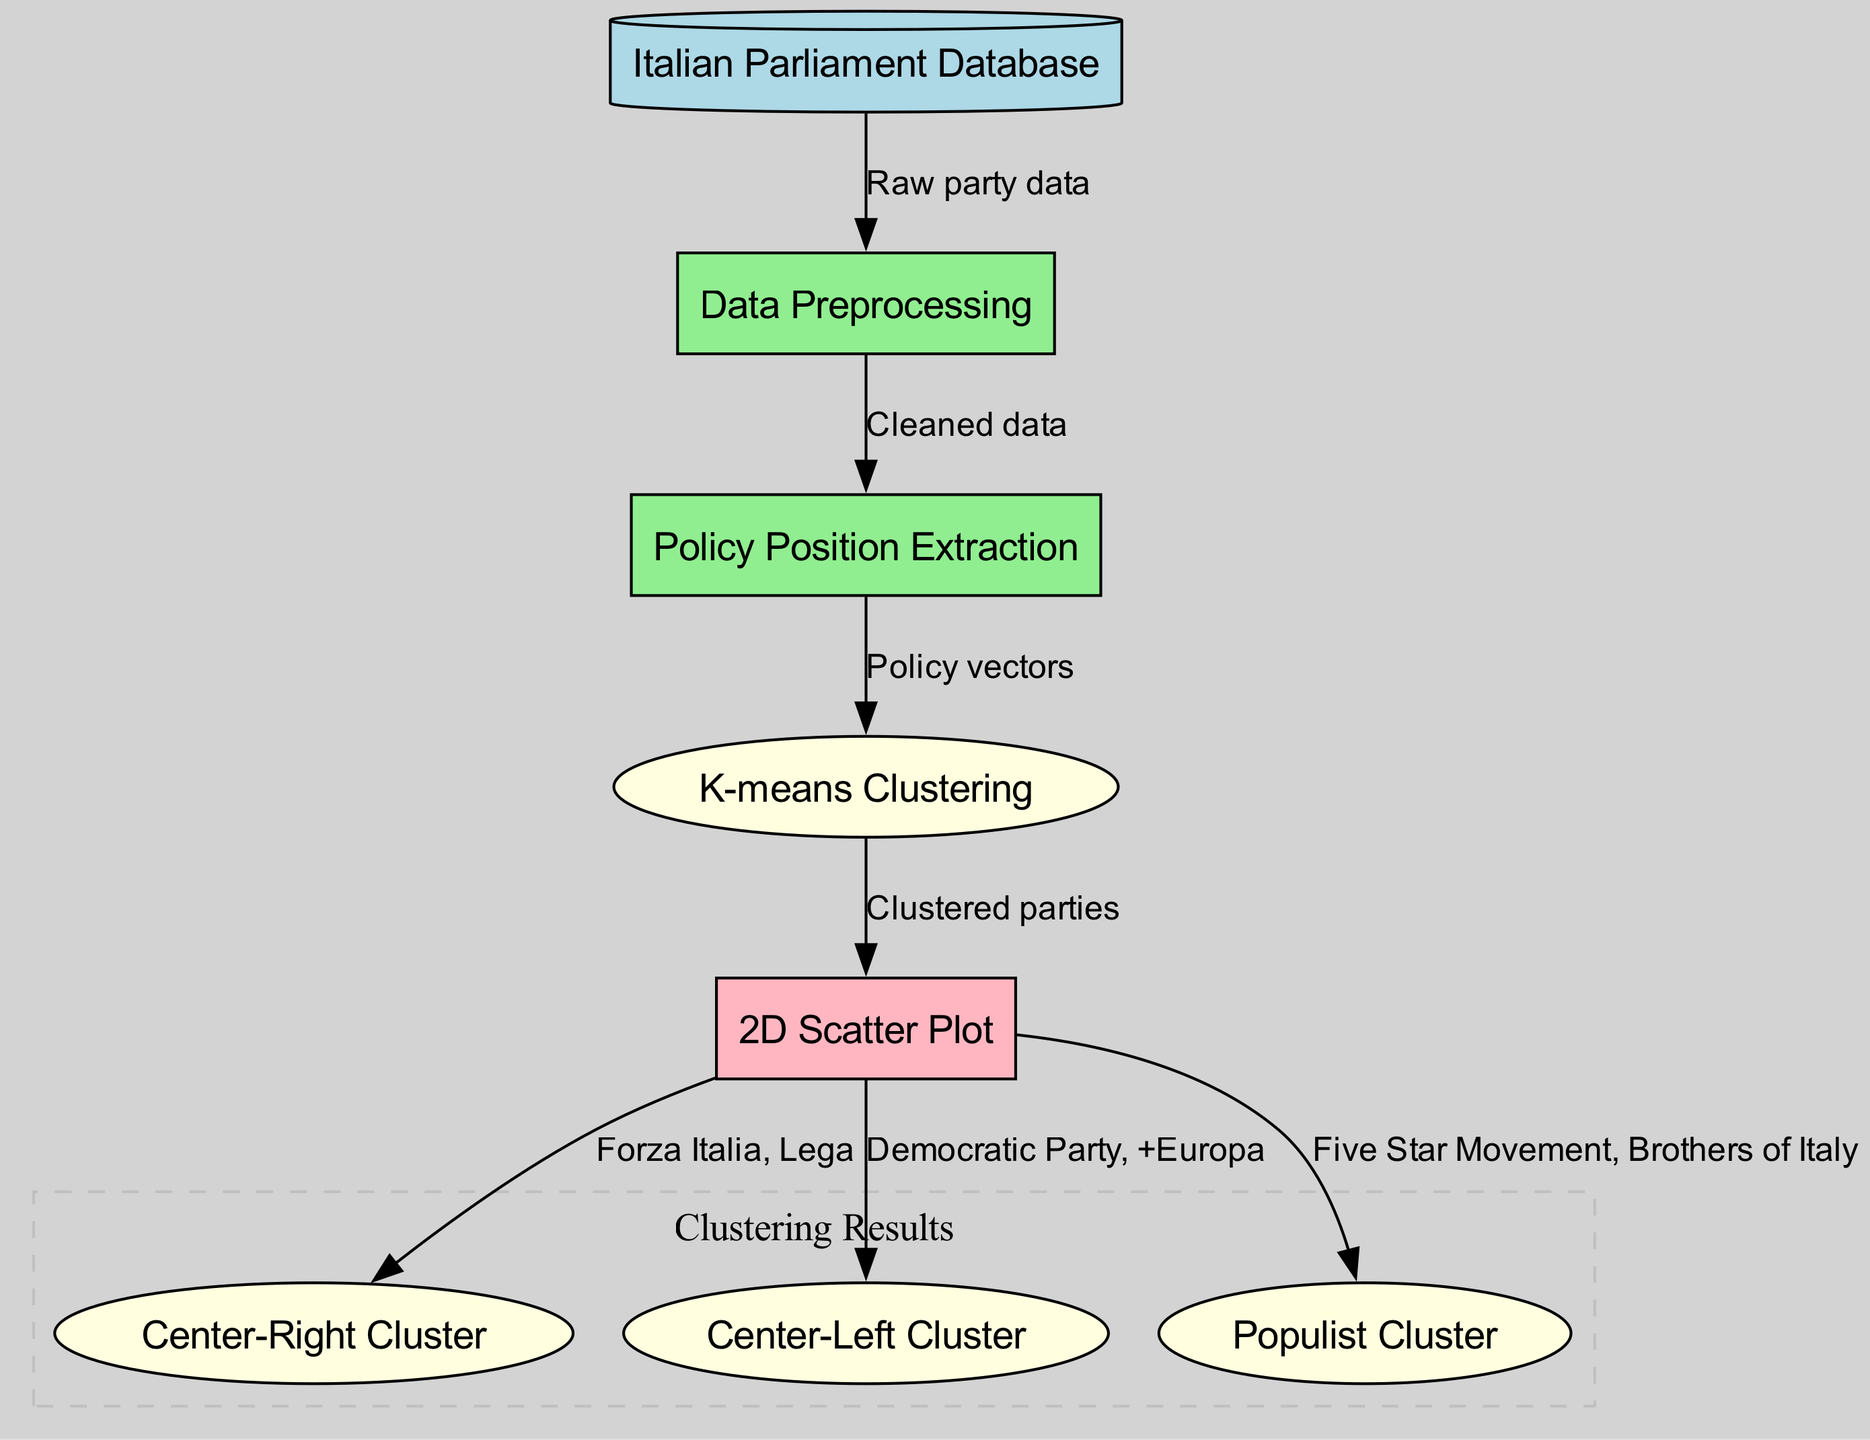What is the data source for this diagram? The diagram indicates that the data source is the "Italian Parliament Database," which serves as the starting point for the entire process.
Answer: Italian Parliament Database How many clusters are visualized in the diagram? The diagram shows three distinct clusters, namely the Center-Right Cluster, Center-Left Cluster, and Populist Cluster, indicating the different groupings of political parties based on their policy positions.
Answer: 3 Which political parties are in the Center-Right Cluster? The diagram identifies "Forza Italia" and "Lega" as the political parties belonging to the Center-Right Cluster, which is visually represented as one of the clustering results.
Answer: Forza Italia, Lega What process follows data preprocessing in the diagram? After data preprocessing, the diagram shows that the next step is "Policy Position Extraction," indicating that the cleaned data is used to extract policy vectors for further analysis.
Answer: Policy Position Extraction Which step produces the policy vectors used for clustering? The "Feature Extraction" step is responsible for generating the policy vectors that are utilized in the clustering process, derived from the cleaned data obtained in the preprocessing phase.
Answer: Feature Extraction Name the political parties in the Populist Cluster. According to the visualization, the Populist Cluster includes the "Five Star Movement" and "Brothers of Italy," indicating their grouping based on similar policy positions.
Answer: Five Star Movement, Brothers of Italy What type of clustering algorithm is used in this diagram? The diagram specifically mentions "K-means Clustering" as the algorithm being applied to group the political parties based on their policy positions.
Answer: K-means Clustering What connection does the visualization have with the clustering step? The diagram shows that the "Visualization" step follows directly from the "Clustering" step, illustrating that clustered parties are then visualized in a 2D Scatter Plot.
Answer: Clustered parties Which node connects "Data Preprocessing" and "Policy Position Extraction"? The connection between "Data Preprocessing" and "Policy Position Extraction" is established by the "Cleaned Data," which signifies the output of the preprocessing phase feeding into the next step.
Answer: Cleaned Data 